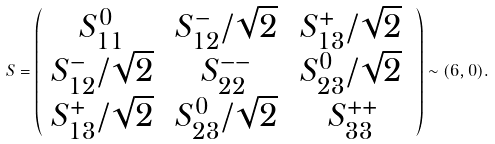<formula> <loc_0><loc_0><loc_500><loc_500>S = \left ( \begin{array} { c c c } { { S _ { 1 1 } ^ { 0 } \, } } & { { S _ { 1 2 } ^ { - } / \sqrt { 2 } \, } } & { { S _ { 1 3 } ^ { + } / \sqrt { 2 } \, } } \\ { { S _ { 1 2 } ^ { - } / \sqrt { 2 } \, } } & { { S _ { 2 2 } ^ { - - } \, } } & { { S _ { 2 3 } ^ { 0 } / \sqrt { 2 } \, } } \\ { { S _ { 1 3 } ^ { + } / \sqrt { 2 } \, } } & { { S _ { 2 3 } ^ { 0 } / \sqrt { 2 } \, } } & { { S _ { 3 3 } ^ { + + } } } \end{array} \right ) \sim ( { 6 } , 0 ) .</formula> 